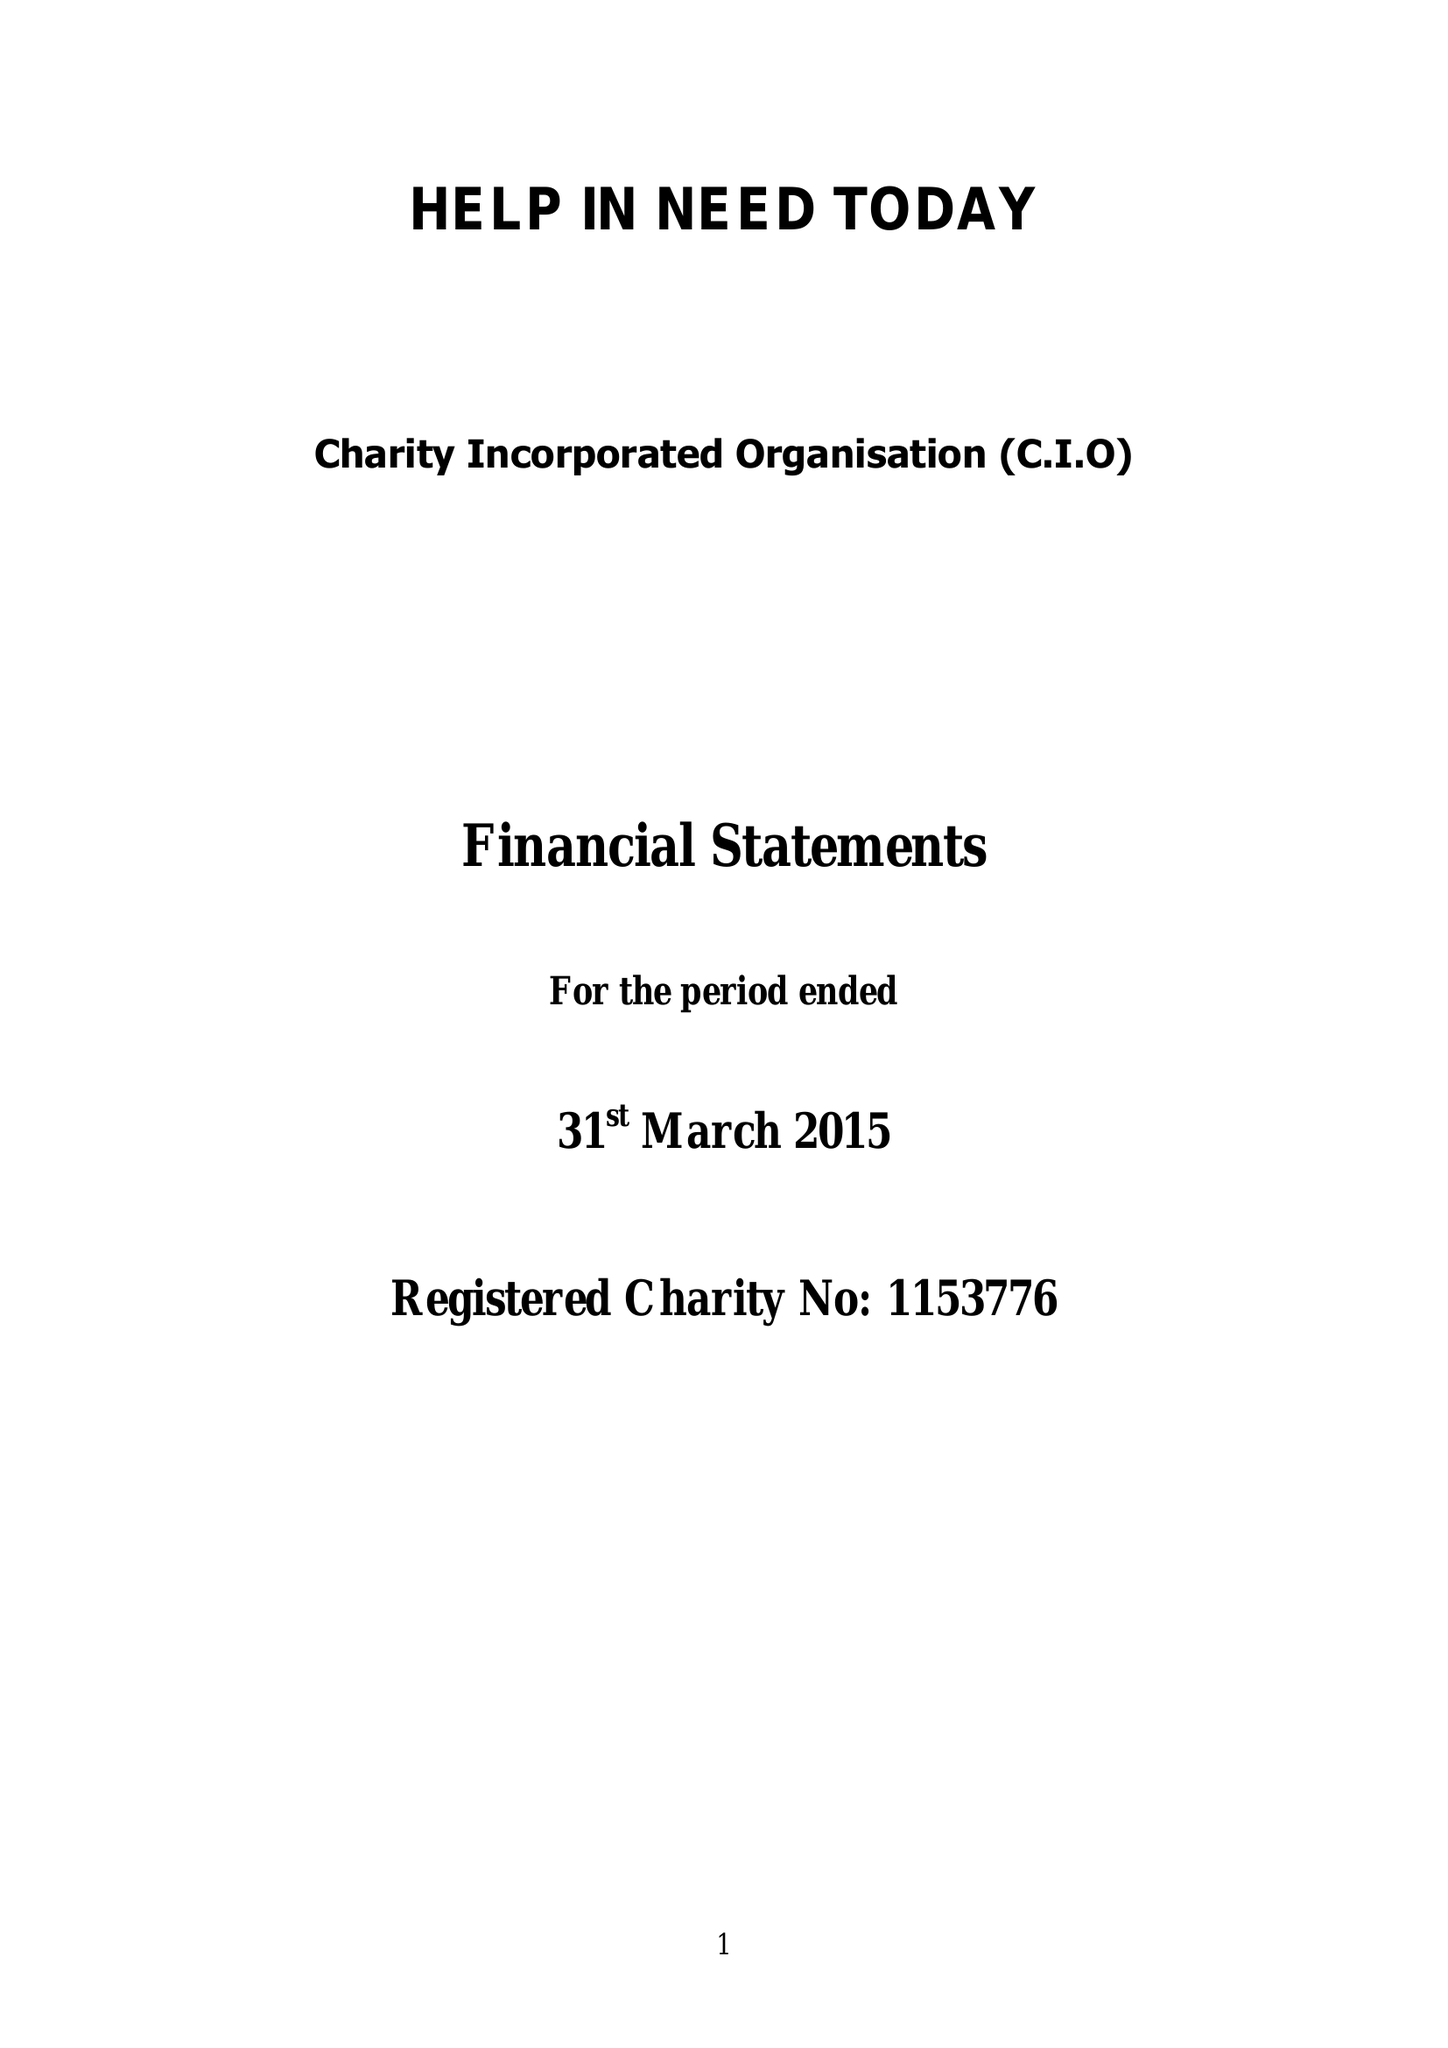What is the value for the income_annually_in_british_pounds?
Answer the question using a single word or phrase. None 